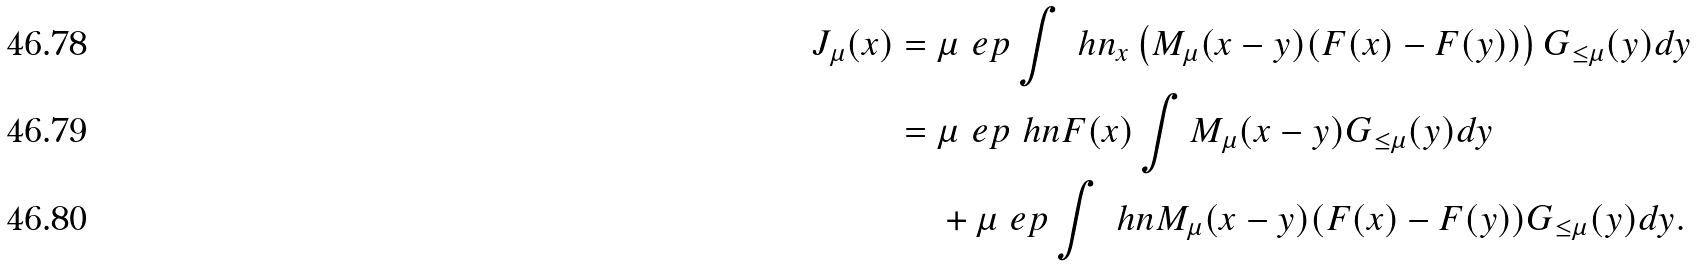<formula> <loc_0><loc_0><loc_500><loc_500>J _ { \mu } ( x ) & = \mu ^ { \ } e p \int \ h n _ { x } \left ( M _ { \mu } ( x - y ) ( F ( x ) - F ( y ) ) \right ) G _ { \leq \mu } ( y ) d y \\ & = \mu ^ { \ } e p \ h n F ( x ) \int M _ { \mu } ( x - y ) G _ { \leq \mu } ( y ) d y \\ & \quad \, + \mu ^ { \ } e p \int \ h n M _ { \mu } ( x - y ) ( F ( x ) - F ( y ) ) G _ { \leq \mu } ( y ) d y .</formula> 